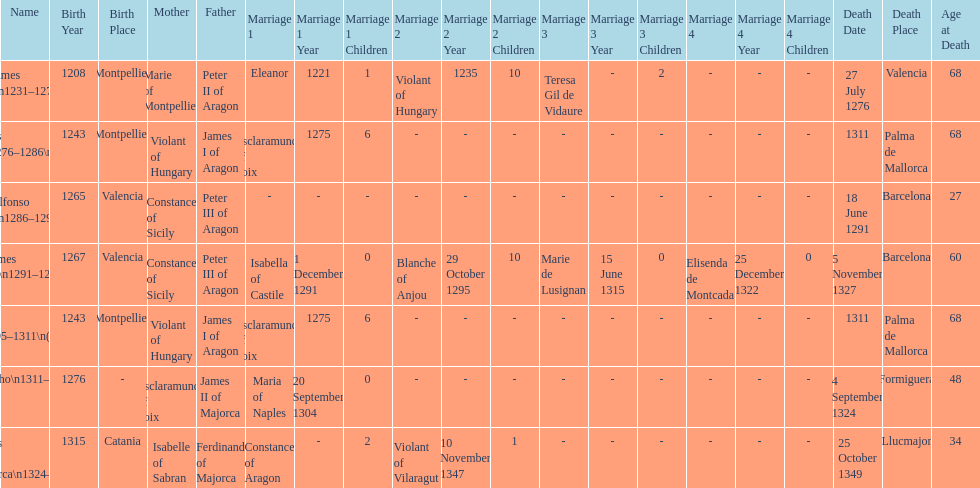How many of these monarchs died before the age of 65? 4. 